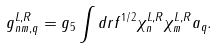<formula> <loc_0><loc_0><loc_500><loc_500>g _ { n m , q } ^ { L , R } = g _ { 5 } \int d r f ^ { 1 / 2 } \chi _ { n } ^ { L , R } \chi _ { m } ^ { L , R } a _ { q } .</formula> 